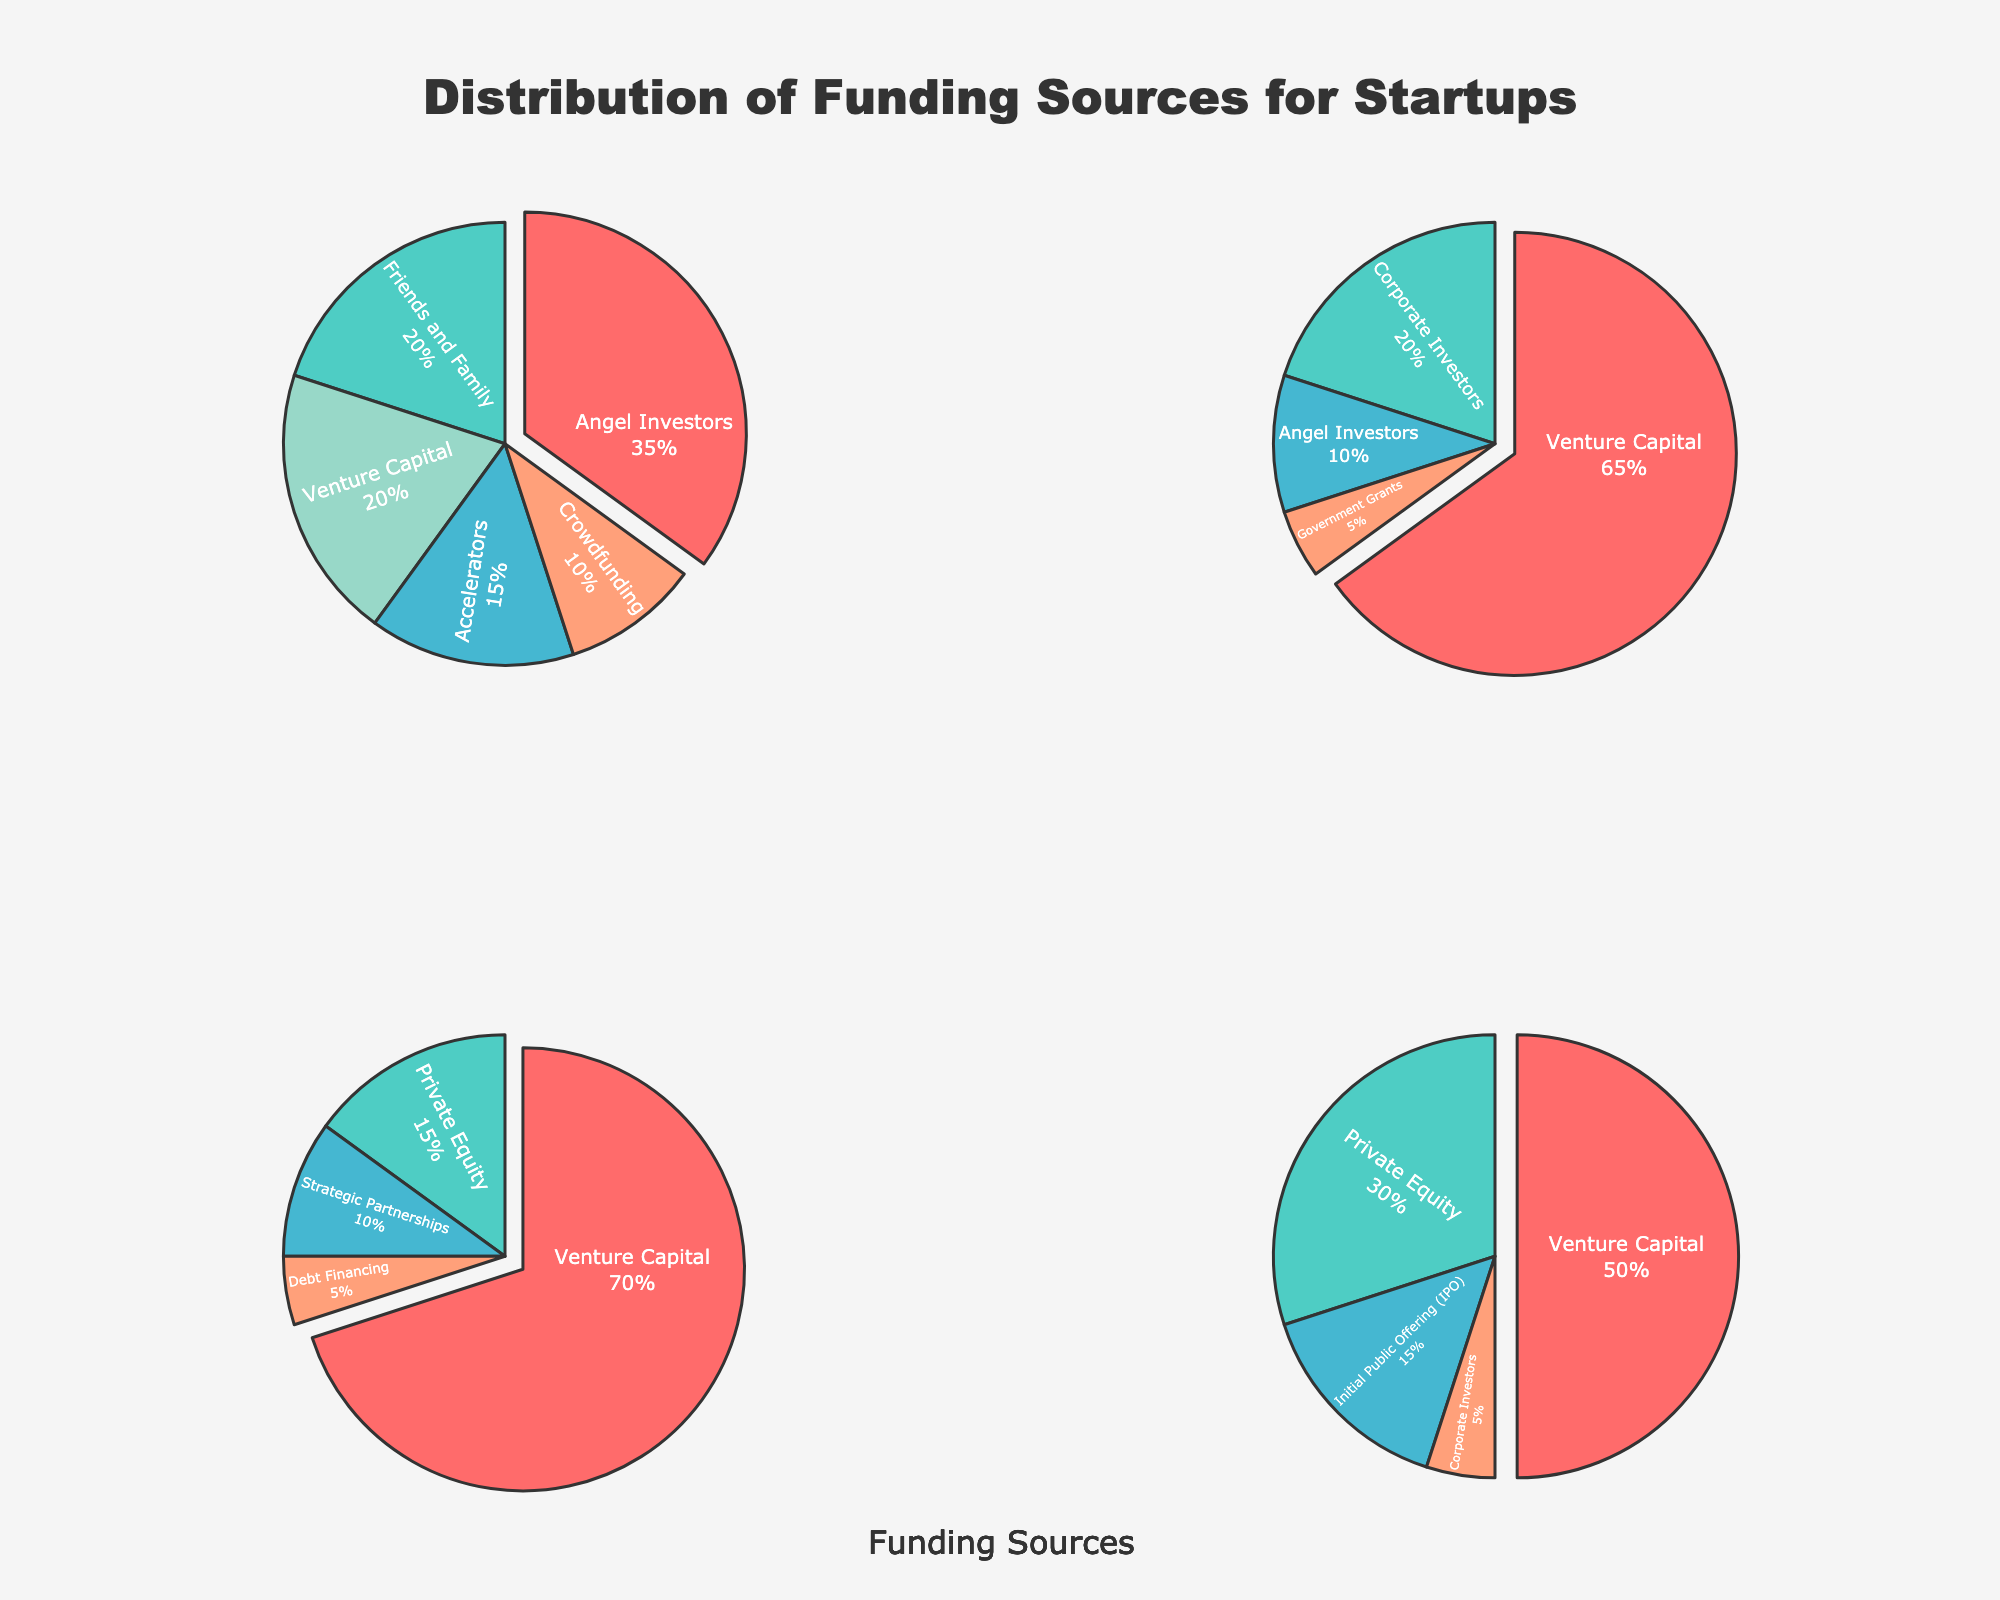How many funding sources are represented in the "Seed" stage? The "Seed" stage pie chart indicates the various funding sources. Counting the labeled segments provides the total number: Angel Investors, Friends and Family, Accelerators, Crowdfunding, and Venture Capital.
Answer: 5 What is the primary funding source in the "Series B" stage? The "Series B" stage pie chart shows the largest segment, indicating that Venture Capital is the dominant source with the highest percentage.
Answer: Venture Capital Which stage has the highest percentage of Venture Capital funding? By examining each pie chart, we see that the Series B stage has the largest segment dedicated to Venture Capital, indicating it has the highest percentage.
Answer: Series B What is the combined percentage of Angel Investors across all stages? Adding the percentage of Angel Investors from Seed (35%) and Series A (10%) gives a total of 35% + 10%. There are no Angel Investors in Series B and C.
Answer: 45% Which funding source appears in all stages? By checking each pie chart, we can see that Venture Capital appears in Seed, Series A, Series B, and Series C. This is the only source present in all stages.
Answer: Venture Capital What is the percentage difference between Venture Capital funding in Series A and Series C? Series A shows 65% for Venture Capital while Series C shows 50%. The difference is calculated as 65% - 50%.
Answer: 15% How do Corporate Investors' percentages compare between Series A and Series C? Series A has 20% for Corporate Investors, while Series C has 5%. Therefore, Series A has a higher percentage by 15%.
Answer: Series A is higher by 15% What is the total percentage for non-Venture Capital funding sources in Series B? Summing up all the non-Venture Capital sources in Series B: Private Equity (15%), Strategic Partnerships (10%), and Debt Financing (5%) gives 15% + 10% + 5%.
Answer: 30% Is Crowdfunding a significant funding source in later stages? Crowdfunding is only present in the Seed stage with 10% and does not appear in Series A, B, or C, indicating it is not significant in later stages.
Answer: No Which funding source is unique to the Series C stage? By looking at each pie chart, we can see that the Initial Public Offering (IPO) is present only in Series C.
Answer: Initial Public Offering (IPO) 